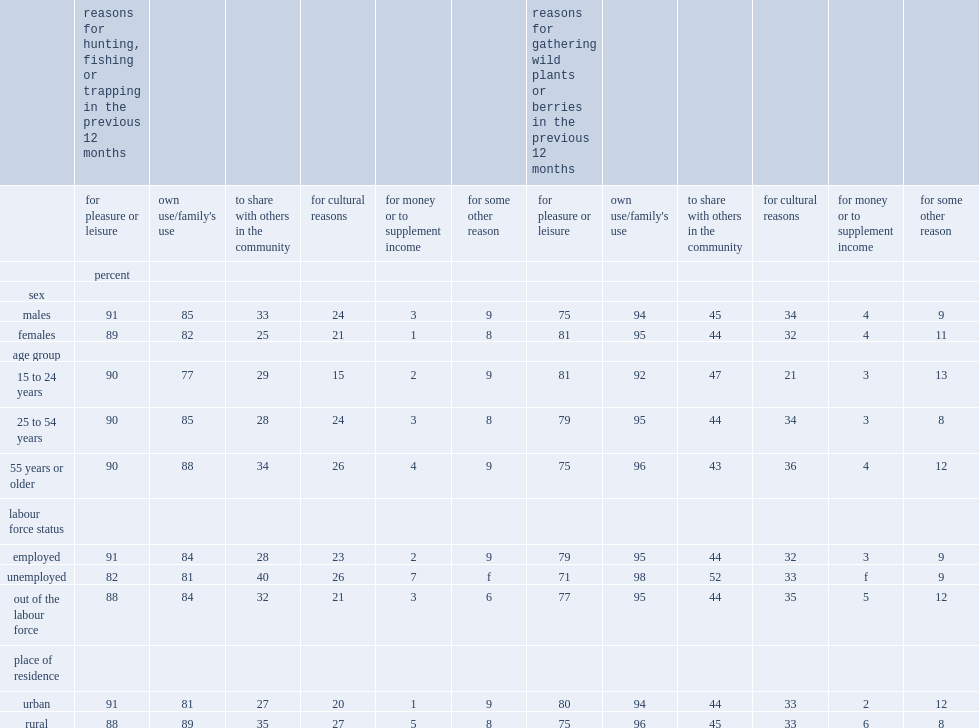Which age group was less likely to hunt, fish or trap for own use or own family's use, youth and young adults or core working-age adults? 15 to 24 years. Which age group was less likely to hunt, fish or trap for own use or own family's use, youth and young adults or older adults? 15 to 24 years. Which area of people were more likely to hunt, fish or trap for own use or own family's use, in rural or urban areas? Rural. Which type of metis were more likely to hunt, fish or trap to share with others in the community, employed or unemployed metis? Unemployed. Which type of metis were more likely to hunt, fish or trap to share with others in the community, rural or urban metis? Rural. Which age group was less likely to hunt, fish or trap for cultural reasons, youth and young adults or working-age adults? 15 to 24 years. Which age group was less likely to hunt, fish or trap for cultural reasons, youth and young adults or older adults? 15 to 24 years. Which area of individuals were more likely to hunt, fish or trap to share with others in the community, rural or urban metis? Rural. How many times were metis males as likely to hunt, fish or trap for money or to supplement income as females? 3. Which type of individuals were more likely to hunt, fish or trap for money or to supplement income, employed individuals or unemployed individuals? Unemployed. Which type of individuals were more likely to hunt, fish or trap for money or to supplement income, out-of-the-labour-force individuals or unemployed individuals? Unemployed. Which area of metis were more likely to hunt, fish or trap for money or to supplement income, in rural or urban areas? Rural. 